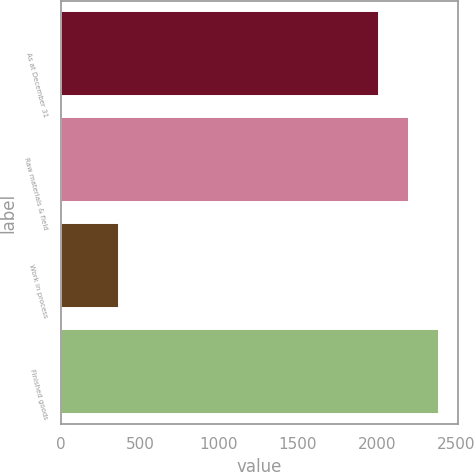Convert chart. <chart><loc_0><loc_0><loc_500><loc_500><bar_chart><fcel>As at December 31<fcel>Raw materials & field<fcel>Work in process<fcel>Finished goods<nl><fcel>2011<fcel>2201.6<fcel>364<fcel>2392.2<nl></chart> 